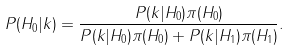Convert formula to latex. <formula><loc_0><loc_0><loc_500><loc_500>P ( H _ { 0 } | k ) = { \frac { P ( k | H _ { 0 } ) \pi ( H _ { 0 } ) } { P ( k | H _ { 0 } ) \pi ( H _ { 0 } ) + P ( k | H _ { 1 } ) \pi ( H _ { 1 } ) } } .</formula> 